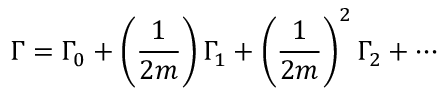<formula> <loc_0><loc_0><loc_500><loc_500>\Gamma = \Gamma _ { 0 } + \left ( \frac { 1 } { 2 m } \right ) \Gamma _ { 1 } + \left ( \frac { 1 } { 2 m } \right ) ^ { 2 } \Gamma _ { 2 } + \cdots</formula> 